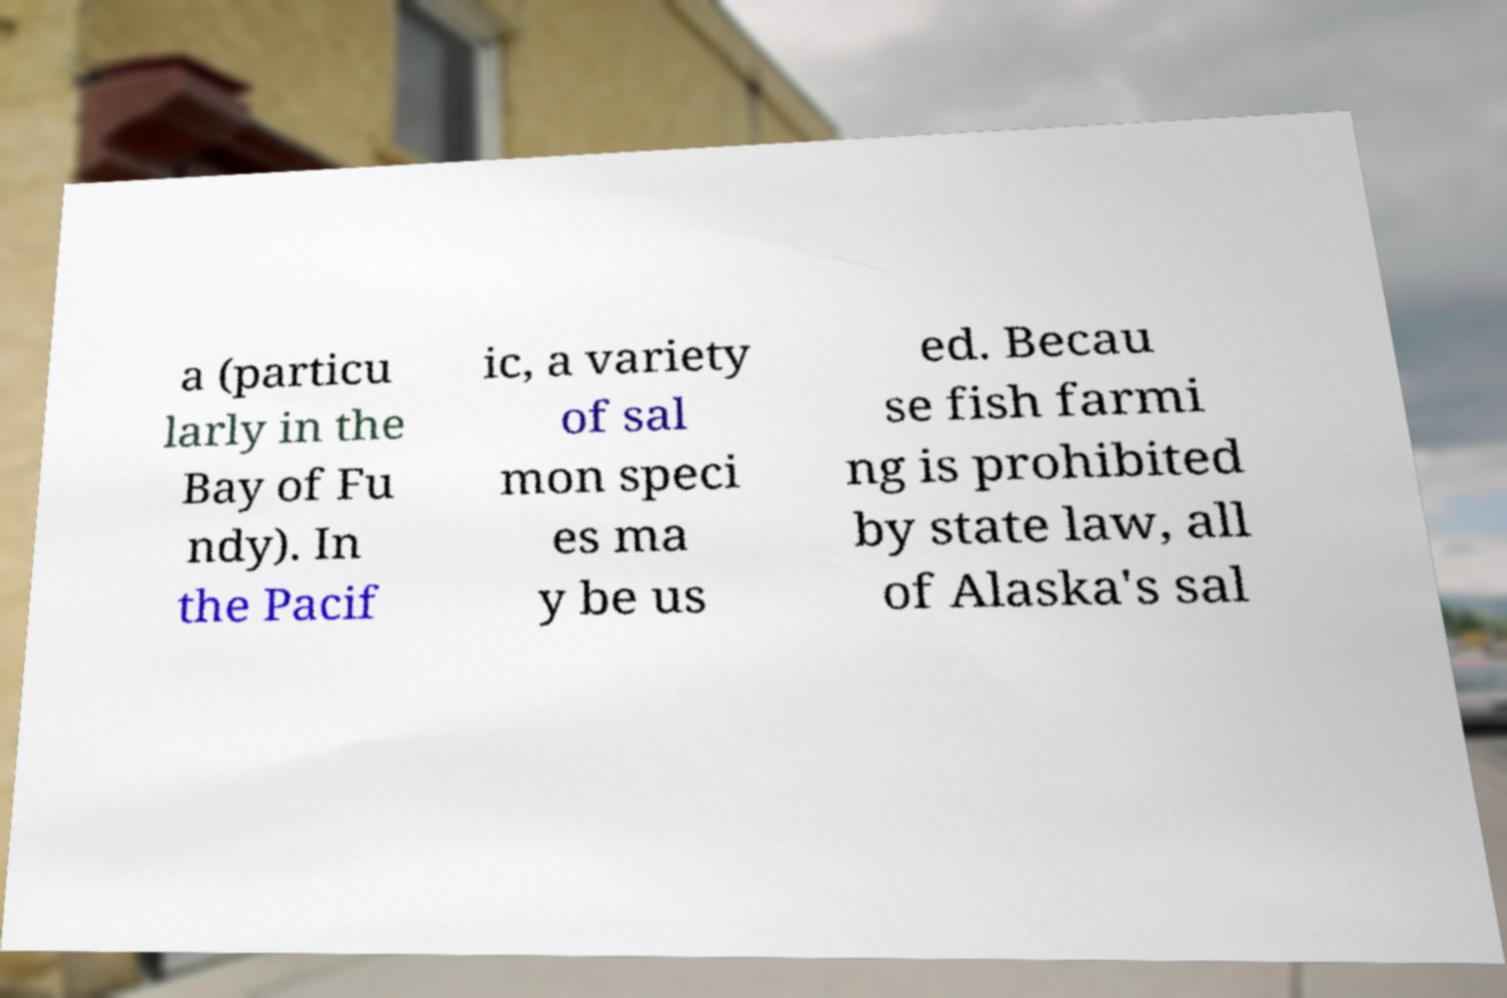Can you accurately transcribe the text from the provided image for me? a (particu larly in the Bay of Fu ndy). In the Pacif ic, a variety of sal mon speci es ma y be us ed. Becau se fish farmi ng is prohibited by state law, all of Alaska's sal 